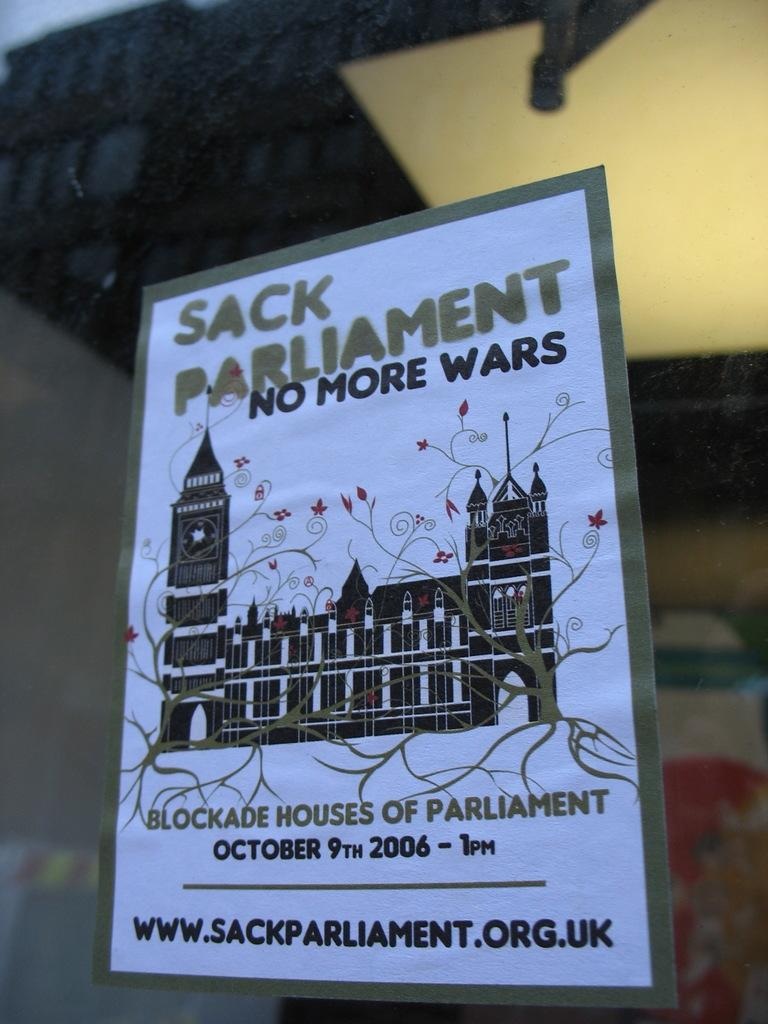<image>
Render a clear and concise summary of the photo. The 'Sack Parliament' flyer encourages 'No more wars' and a blockade of Parliament on October 9th, 2006. 